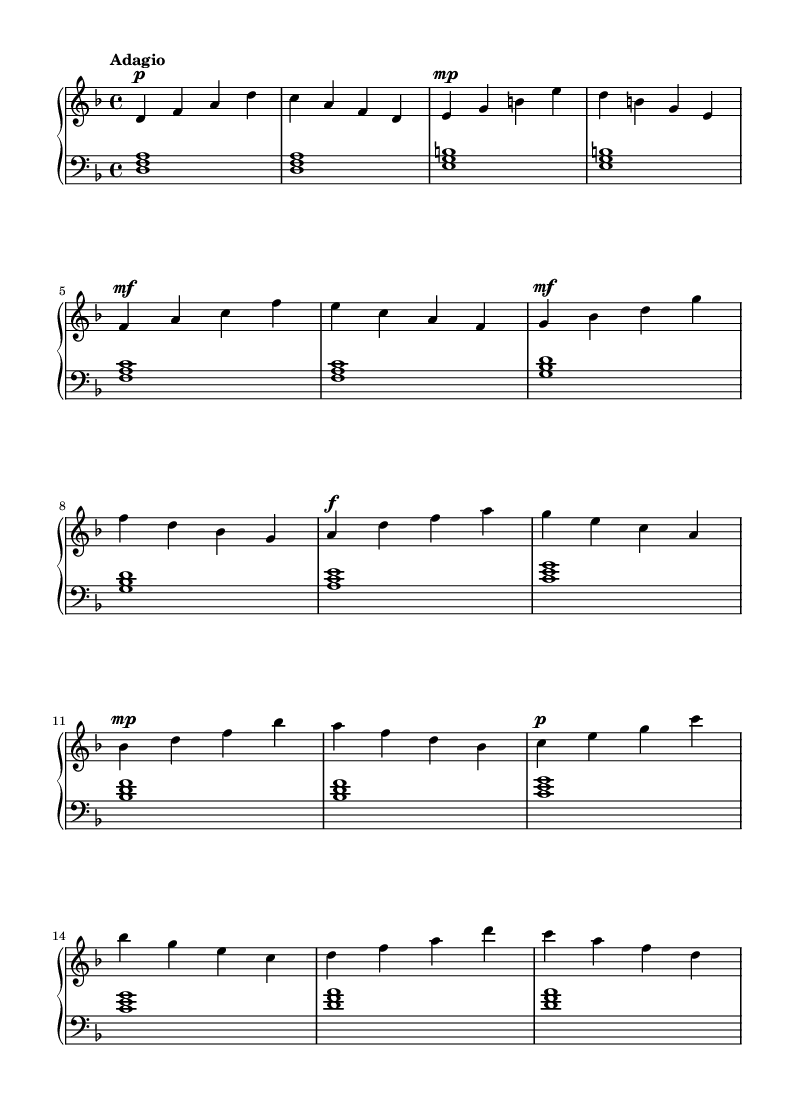What is the key signature of this music? The key signature is indicated by the sharps or flats placed at the beginning of the staff. In this case, there is one flat (B flat) in the key signature, which is characteristic of D minor.
Answer: D minor What is the time signature of this music? The time signature is determined by the number of beats in a measure and the note value that gets one beat. Here, the '4/4' notation indicates four beats per measure, with the quarter note receiving one beat.
Answer: 4/4 What is the tempo marking of this piece? The tempo marking is written above the staff, specifying the speed of the piece. The term "Adagio" indicates a slow tempo.
Answer: Adagio How many measures are there in the upper staff? The upper staff shows the number of measures that can be counted in the notated music. By counting the vertical lines (bar lines) that separate the measures, we find there are 14 measures.
Answer: 14 What type of composition is this? This piece displays characteristics typical of Romantic music, such as expressive dynamics and lyrical melodies, making it identifiable as a Romantic piano composition.
Answer: Romantic What dynamic marking is found in the first measure? The first measure indicates a dynamic marking through the notation. The 'p' stands for piano, which means soft.
Answer: piano How many distinct sections does the lower staff contain? The lower staff represents chordal structures, each unique set of notes corresponds to music sections, indicating that there are seven distinct harmonic sections in this composition.
Answer: 7 